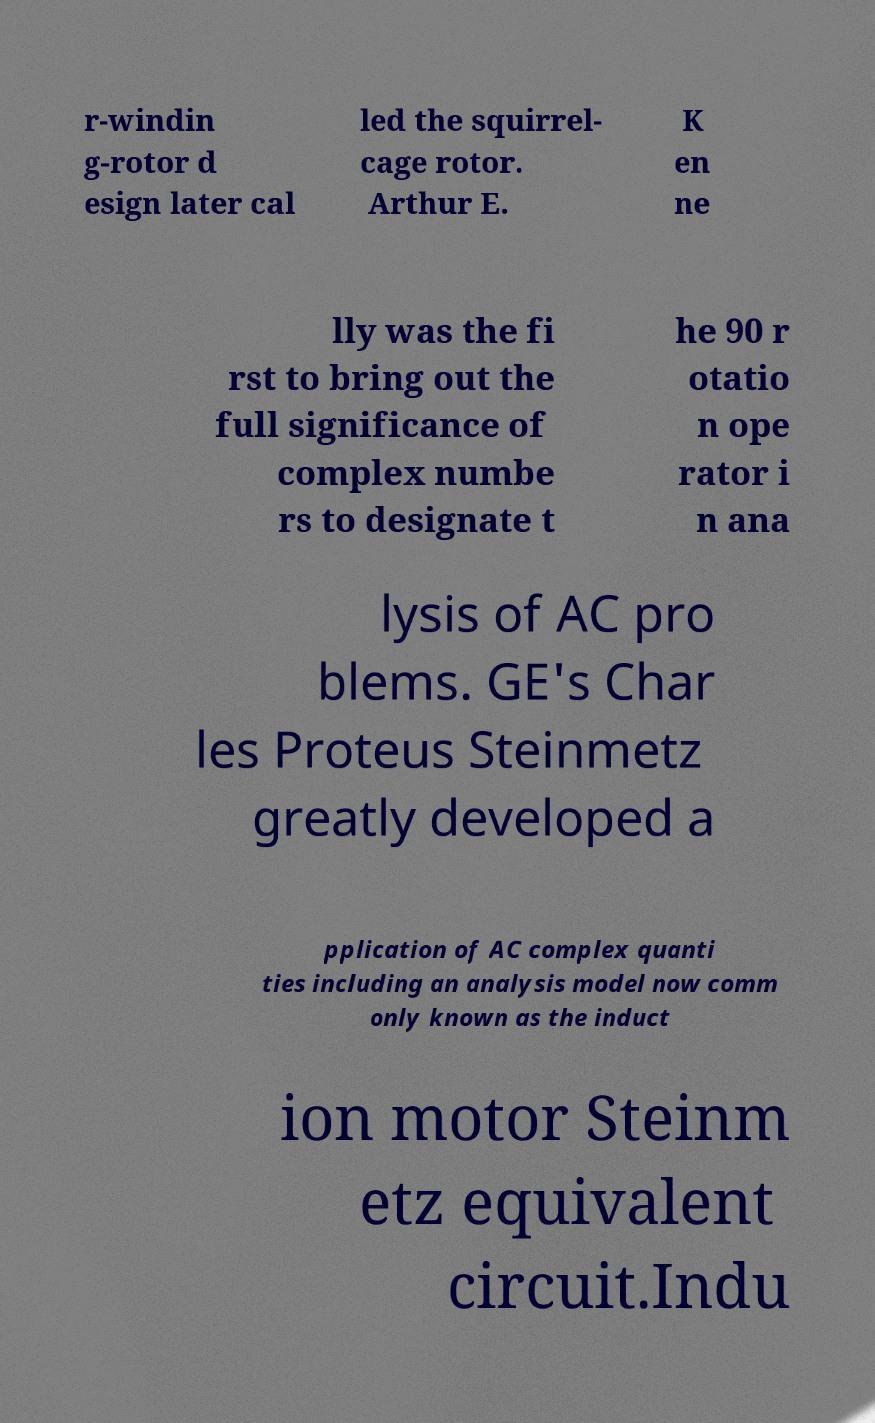What messages or text are displayed in this image? I need them in a readable, typed format. r-windin g-rotor d esign later cal led the squirrel- cage rotor. Arthur E. K en ne lly was the fi rst to bring out the full significance of complex numbe rs to designate t he 90 r otatio n ope rator i n ana lysis of AC pro blems. GE's Char les Proteus Steinmetz greatly developed a pplication of AC complex quanti ties including an analysis model now comm only known as the induct ion motor Steinm etz equivalent circuit.Indu 